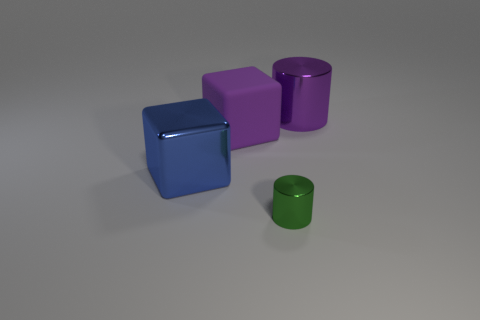Add 4 shiny cylinders. How many objects exist? 8 Add 2 big blue shiny cubes. How many big blue shiny cubes exist? 3 Subtract 1 purple cubes. How many objects are left? 3 Subtract all big purple balls. Subtract all big matte things. How many objects are left? 3 Add 2 blue blocks. How many blue blocks are left? 3 